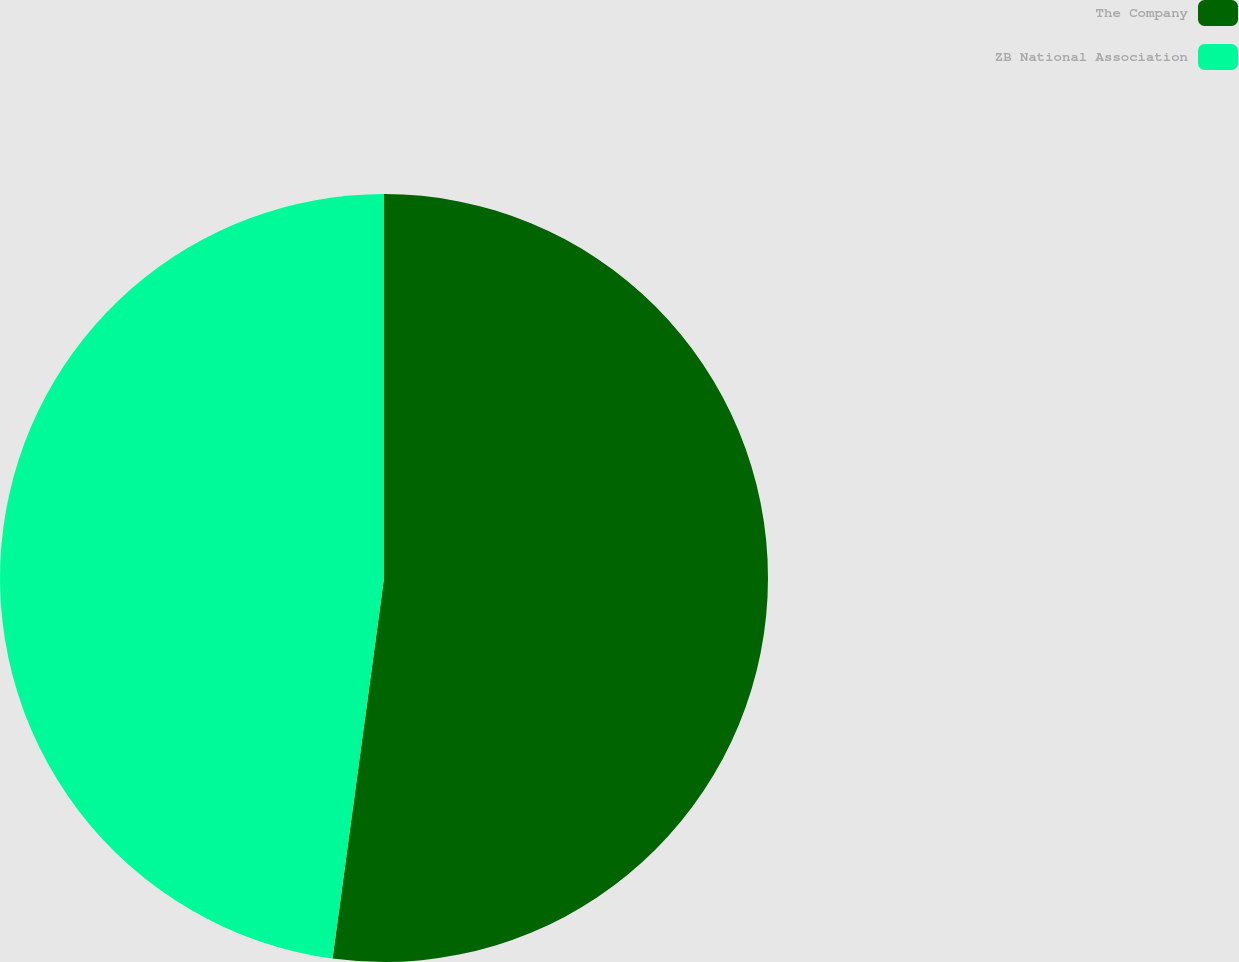Convert chart. <chart><loc_0><loc_0><loc_500><loc_500><pie_chart><fcel>The Company<fcel>ZB National Association<nl><fcel>52.14%<fcel>47.86%<nl></chart> 